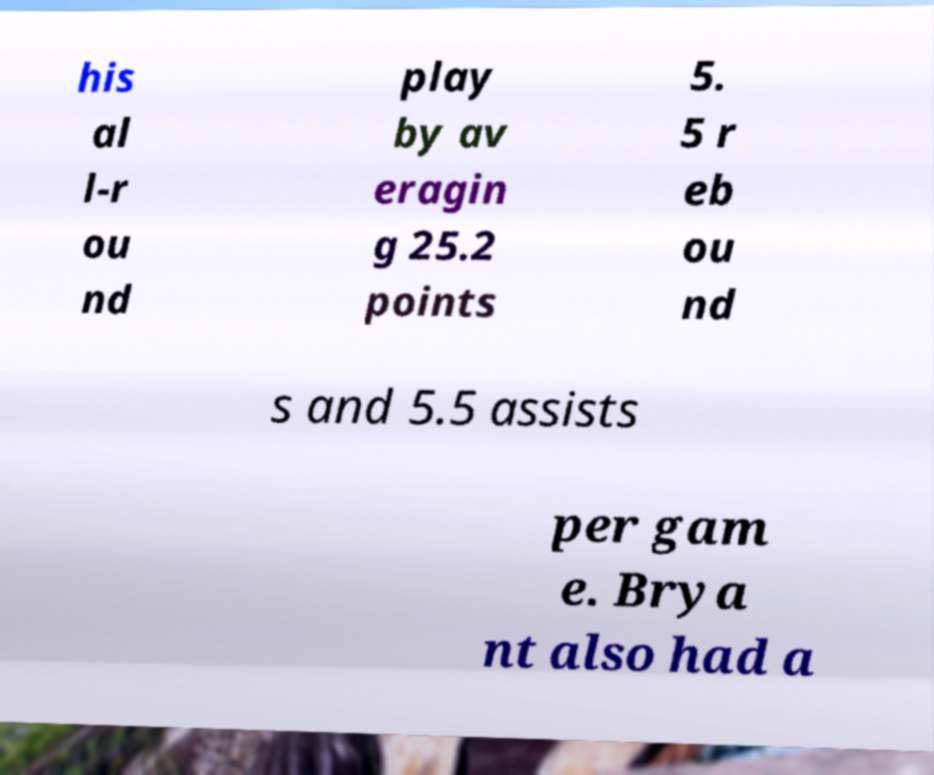I need the written content from this picture converted into text. Can you do that? his al l-r ou nd play by av eragin g 25.2 points 5. 5 r eb ou nd s and 5.5 assists per gam e. Brya nt also had a 